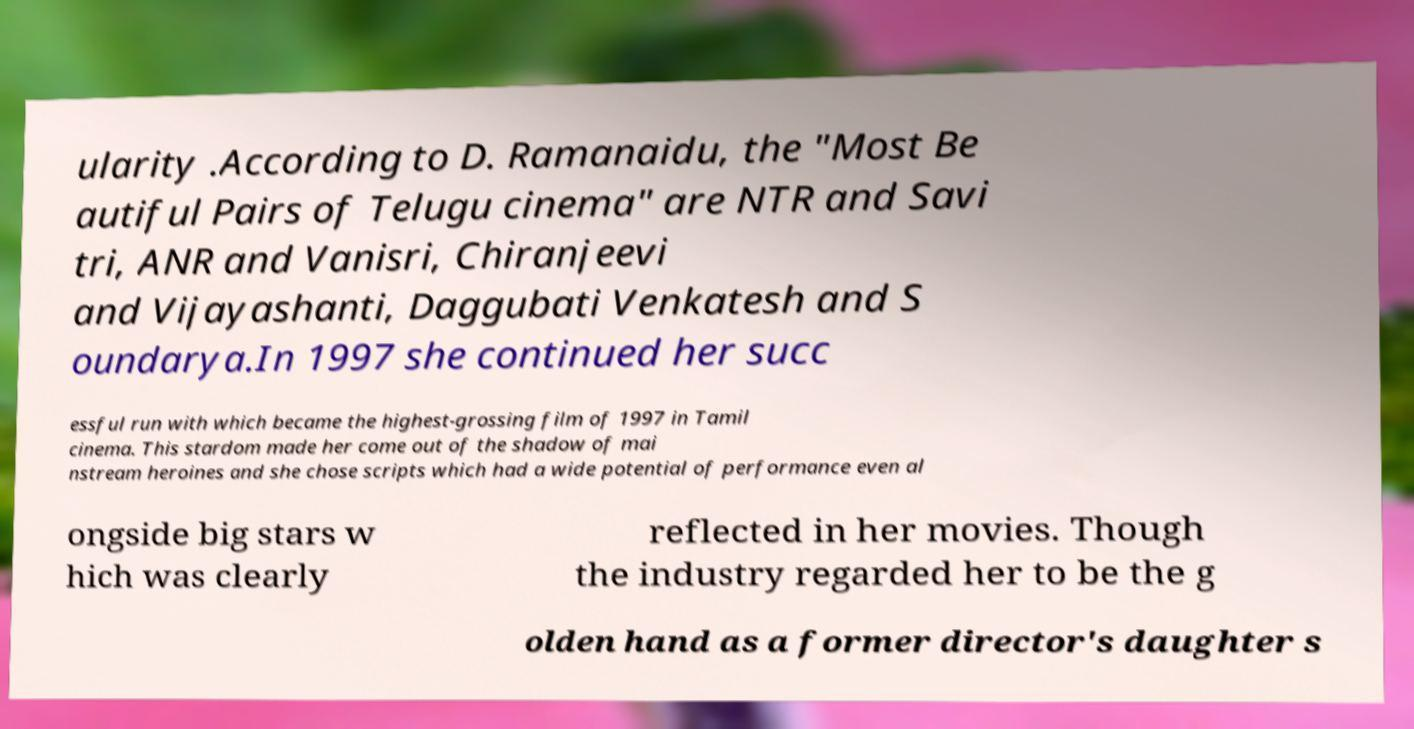Please identify and transcribe the text found in this image. ularity .According to D. Ramanaidu, the "Most Be autiful Pairs of Telugu cinema" are NTR and Savi tri, ANR and Vanisri, Chiranjeevi and Vijayashanti, Daggubati Venkatesh and S oundarya.In 1997 she continued her succ essful run with which became the highest-grossing film of 1997 in Tamil cinema. This stardom made her come out of the shadow of mai nstream heroines and she chose scripts which had a wide potential of performance even al ongside big stars w hich was clearly reflected in her movies. Though the industry regarded her to be the g olden hand as a former director's daughter s 